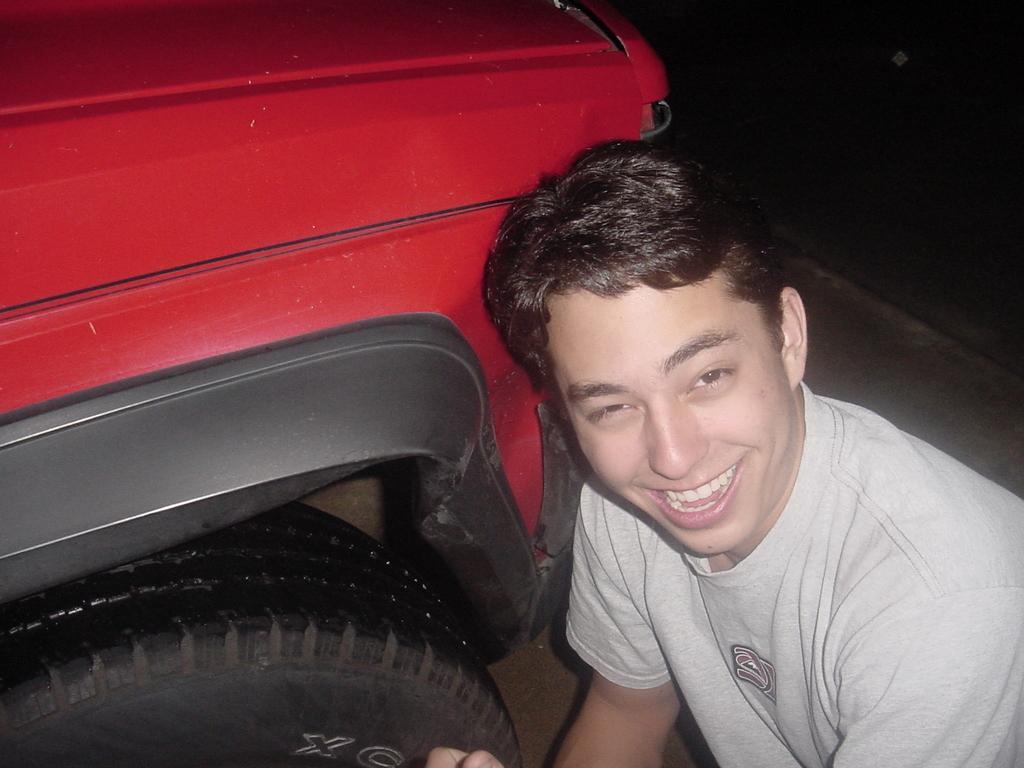Can you describe this image briefly? On the right side a man is smiling,he wore t-shirt. On the left side there is a vehicle in red color. 